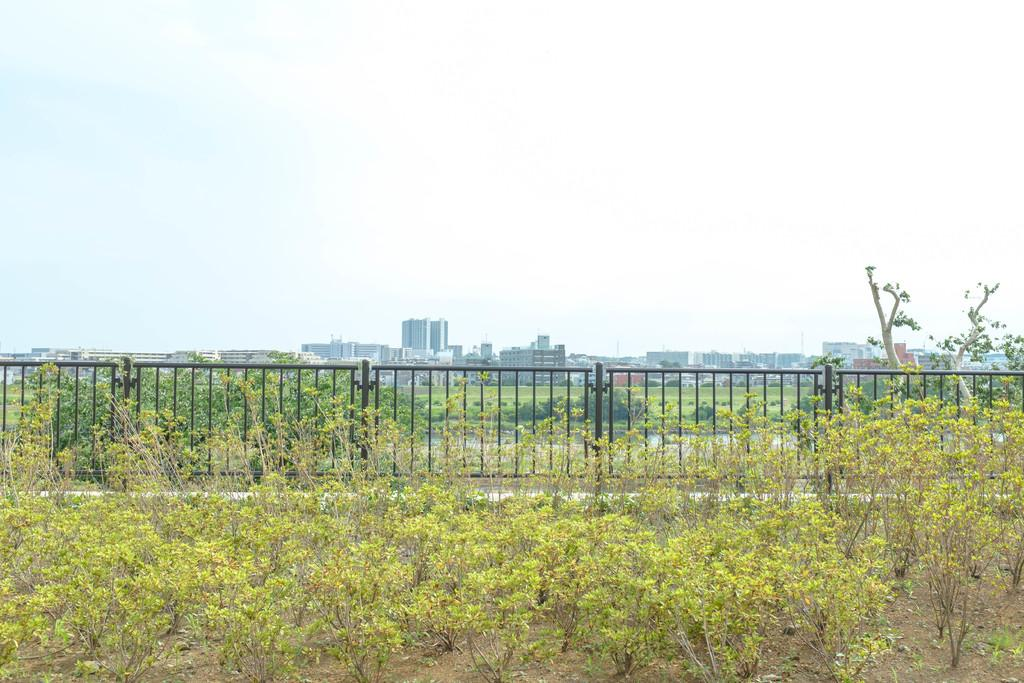What can be seen in the image that might be used for support or safety? There is a railing in the image that might be used for support or safety. What type of natural environment is visible in the image? There are many trees visible in the image, indicating a natural environment. What type of man-made structures can be seen in the image? There are buildings in the background of the image. What is visible in the sky in the image? The sky is visible in the background of the image. Where is the kettle placed in the image? There is no kettle present in the image. What type of holiday is being celebrated in the image? There is no indication of a holiday being celebrated in the image. 